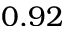Convert formula to latex. <formula><loc_0><loc_0><loc_500><loc_500>0 . 9 2</formula> 